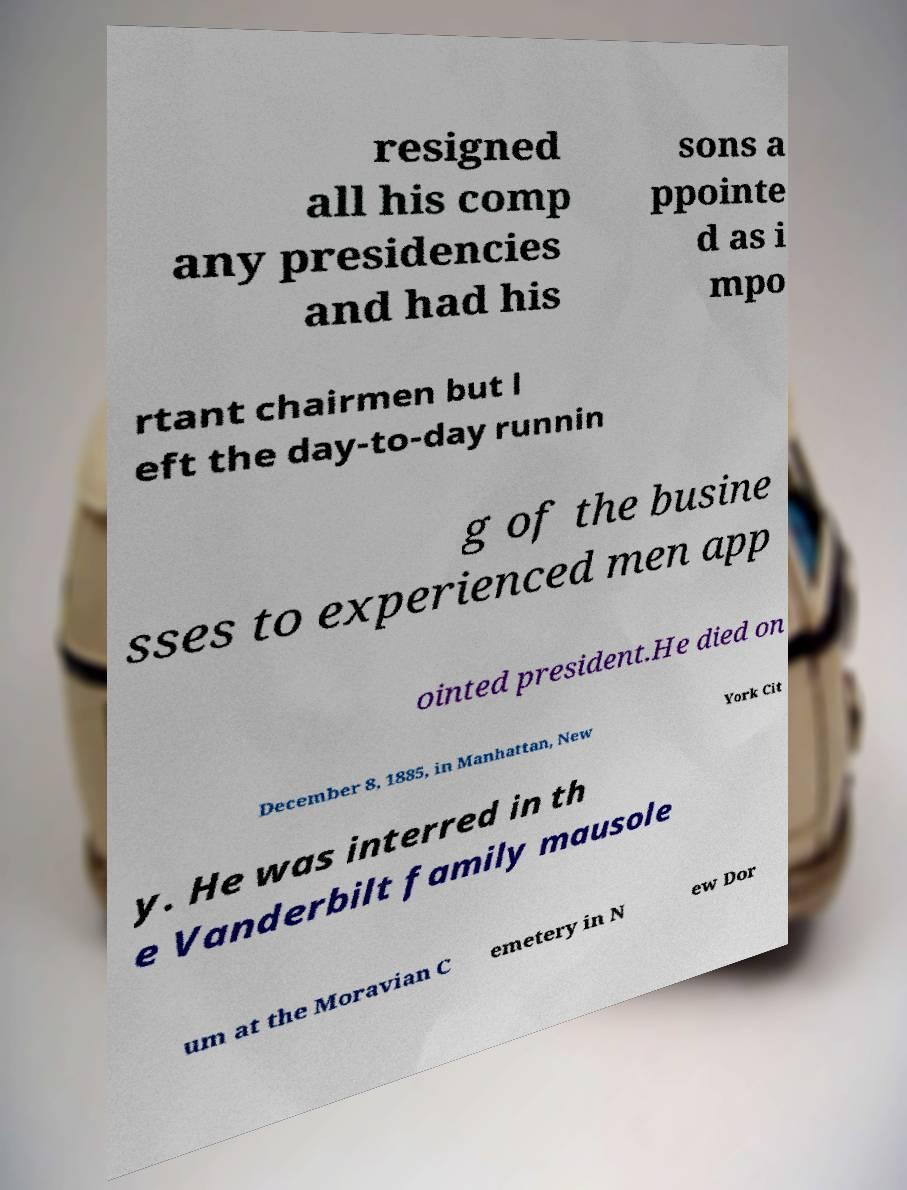What messages or text are displayed in this image? I need them in a readable, typed format. resigned all his comp any presidencies and had his sons a ppointe d as i mpo rtant chairmen but l eft the day-to-day runnin g of the busine sses to experienced men app ointed president.He died on December 8, 1885, in Manhattan, New York Cit y. He was interred in th e Vanderbilt family mausole um at the Moravian C emetery in N ew Dor 